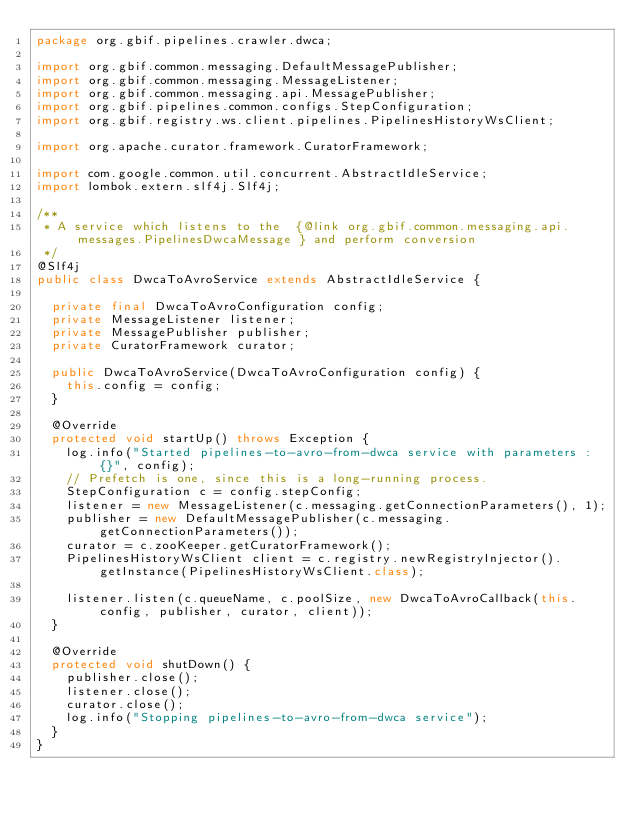<code> <loc_0><loc_0><loc_500><loc_500><_Java_>package org.gbif.pipelines.crawler.dwca;

import org.gbif.common.messaging.DefaultMessagePublisher;
import org.gbif.common.messaging.MessageListener;
import org.gbif.common.messaging.api.MessagePublisher;
import org.gbif.pipelines.common.configs.StepConfiguration;
import org.gbif.registry.ws.client.pipelines.PipelinesHistoryWsClient;

import org.apache.curator.framework.CuratorFramework;

import com.google.common.util.concurrent.AbstractIdleService;
import lombok.extern.slf4j.Slf4j;

/**
 * A service which listens to the  {@link org.gbif.common.messaging.api.messages.PipelinesDwcaMessage } and perform conversion
 */
@Slf4j
public class DwcaToAvroService extends AbstractIdleService {

  private final DwcaToAvroConfiguration config;
  private MessageListener listener;
  private MessagePublisher publisher;
  private CuratorFramework curator;

  public DwcaToAvroService(DwcaToAvroConfiguration config) {
    this.config = config;
  }

  @Override
  protected void startUp() throws Exception {
    log.info("Started pipelines-to-avro-from-dwca service with parameters : {}", config);
    // Prefetch is one, since this is a long-running process.
    StepConfiguration c = config.stepConfig;
    listener = new MessageListener(c.messaging.getConnectionParameters(), 1);
    publisher = new DefaultMessagePublisher(c.messaging.getConnectionParameters());
    curator = c.zooKeeper.getCuratorFramework();
    PipelinesHistoryWsClient client = c.registry.newRegistryInjector().getInstance(PipelinesHistoryWsClient.class);

    listener.listen(c.queueName, c.poolSize, new DwcaToAvroCallback(this.config, publisher, curator, client));
  }

  @Override
  protected void shutDown() {
    publisher.close();
    listener.close();
    curator.close();
    log.info("Stopping pipelines-to-avro-from-dwca service");
  }
}
</code> 